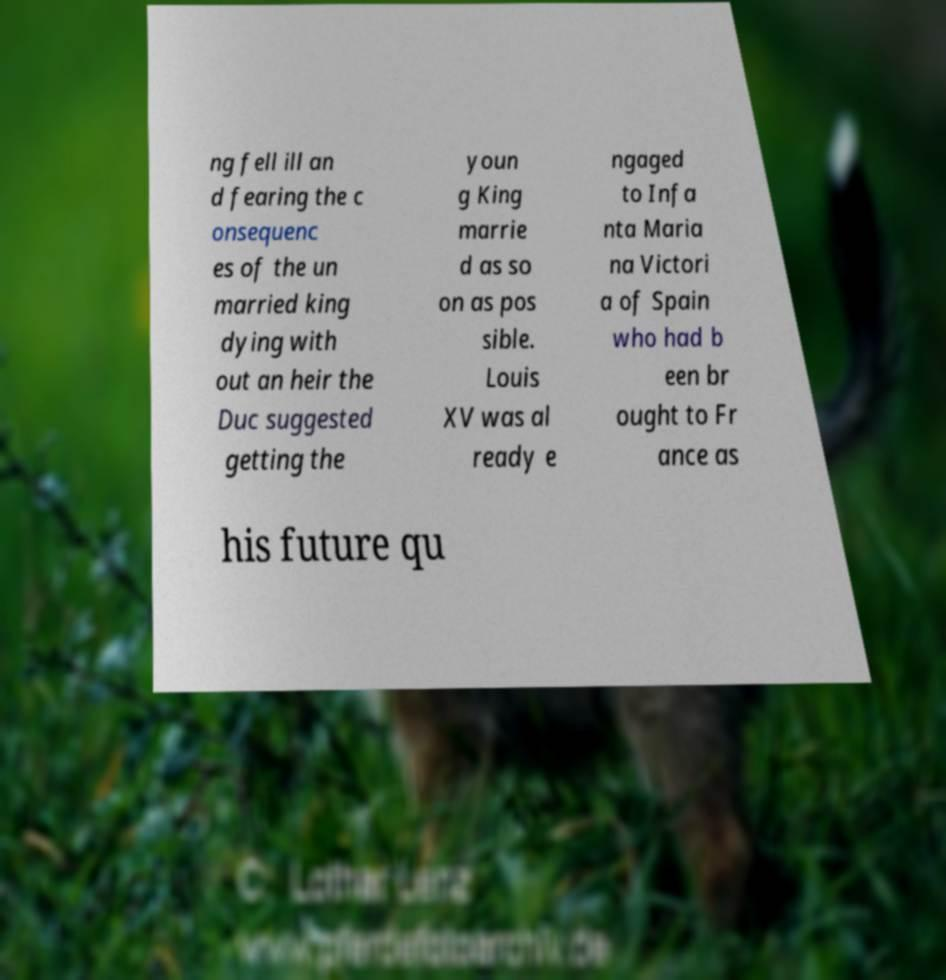Could you extract and type out the text from this image? ng fell ill an d fearing the c onsequenc es of the un married king dying with out an heir the Duc suggested getting the youn g King marrie d as so on as pos sible. Louis XV was al ready e ngaged to Infa nta Maria na Victori a of Spain who had b een br ought to Fr ance as his future qu 